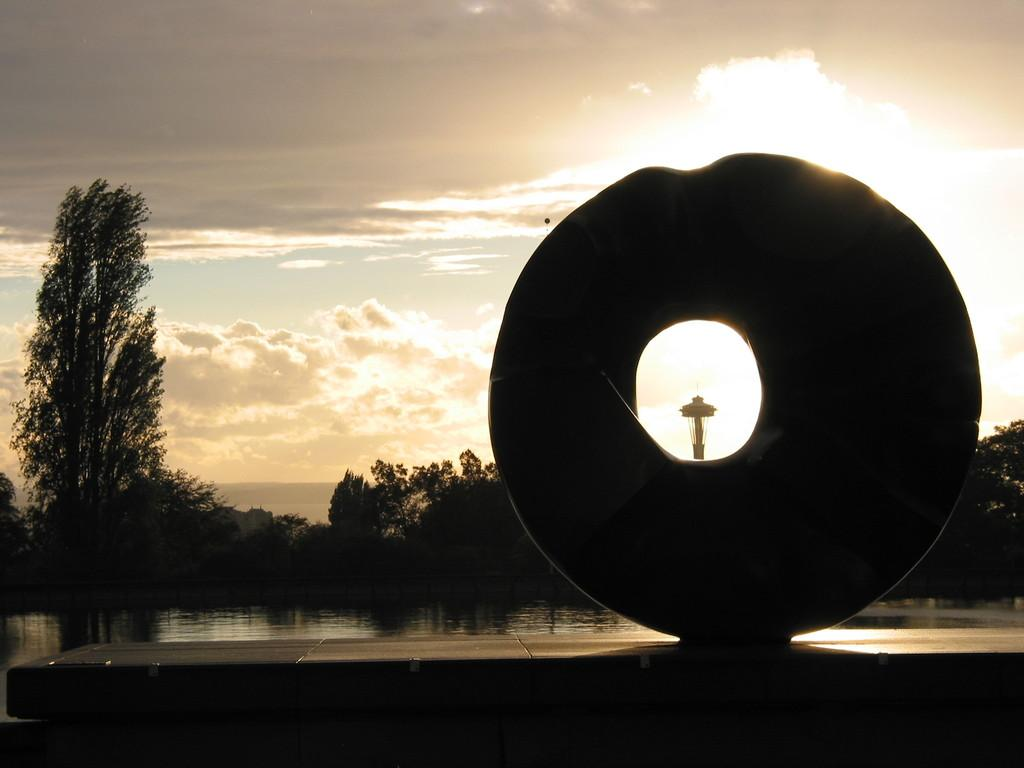What is present in the image that is not solid? There is water visible in the image. What type of natural vegetation can be seen in the image? There are trees in the image. What unique structure is present in the image? There is a huge donut-shaped structure in the image. What can be seen in the distance in the image? The sky is visible in the background of the image. What is the name of the person who made the request for a donut-shaped structure in the image? There is no indication in the image of a person making a request for a donut-shaped structure. 